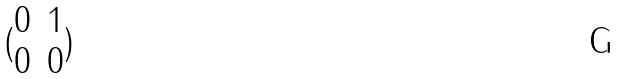Convert formula to latex. <formula><loc_0><loc_0><loc_500><loc_500>( \begin{matrix} 0 & 1 \\ 0 & 0 \end{matrix} )</formula> 